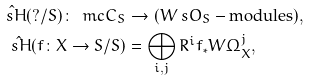Convert formula to latex. <formula><loc_0><loc_0><loc_500><loc_500>\hat { \ s H } ( ? / S ) \colon \ m c { C _ { S } } & \to ( W \ s O _ { S } - \text {modules} ) , \\ \hat { \ s H } ( f \colon X \to S / S ) & = \bigoplus _ { i , j } R ^ { i } f _ { * } W \Omega ^ { j } _ { X } ,</formula> 